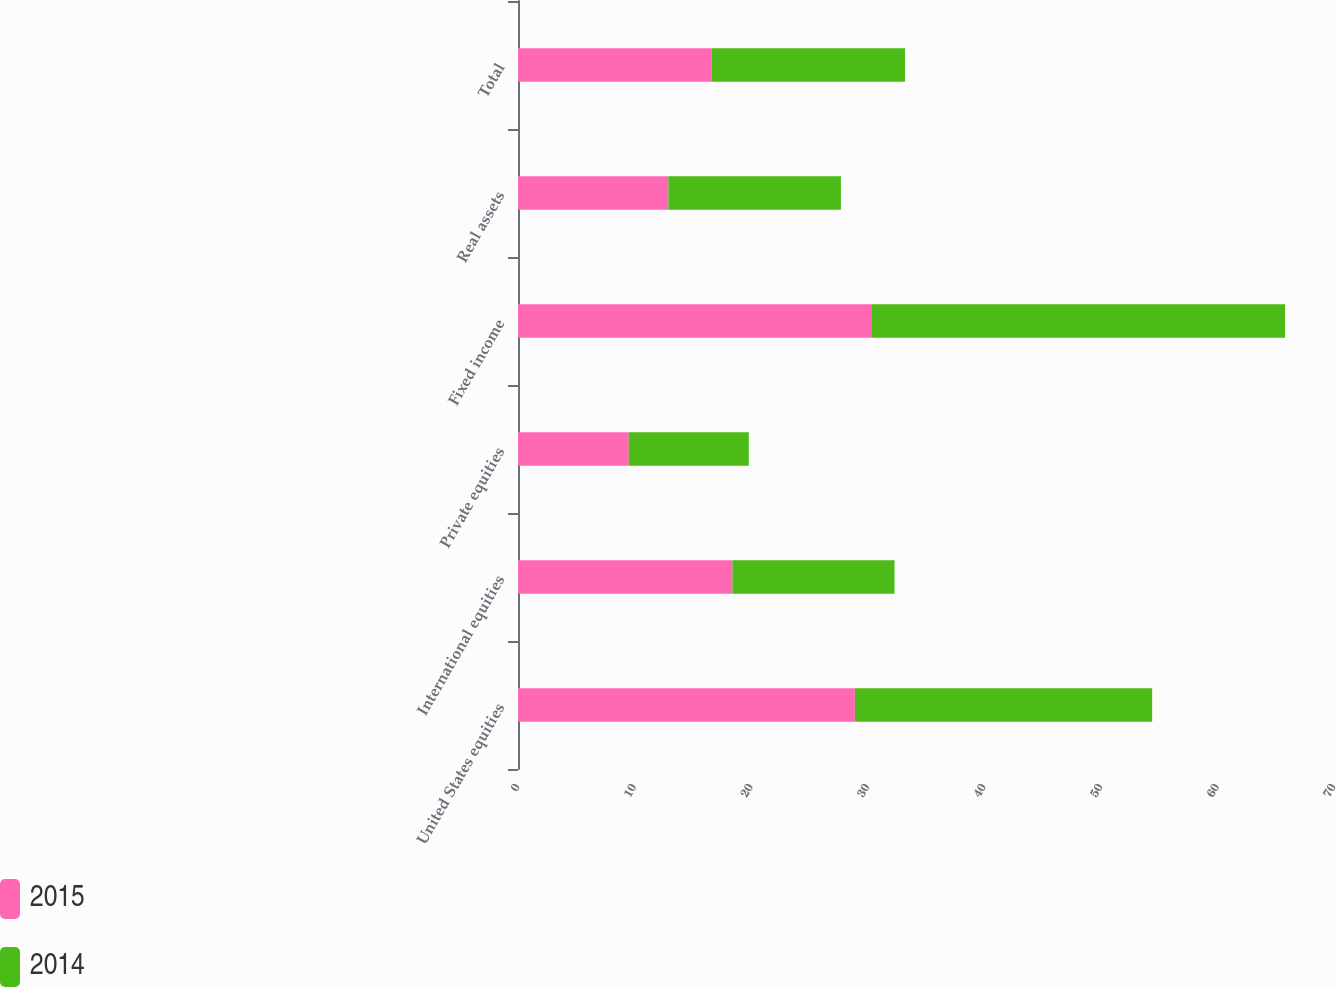<chart> <loc_0><loc_0><loc_500><loc_500><stacked_bar_chart><ecel><fcel>United States equities<fcel>International equities<fcel>Private equities<fcel>Fixed income<fcel>Real assets<fcel>Total<nl><fcel>2015<fcel>28.9<fcel>18.4<fcel>9.5<fcel>30.3<fcel>12.9<fcel>16.6<nl><fcel>2014<fcel>25.5<fcel>13.9<fcel>10.3<fcel>35.5<fcel>14.8<fcel>16.6<nl></chart> 